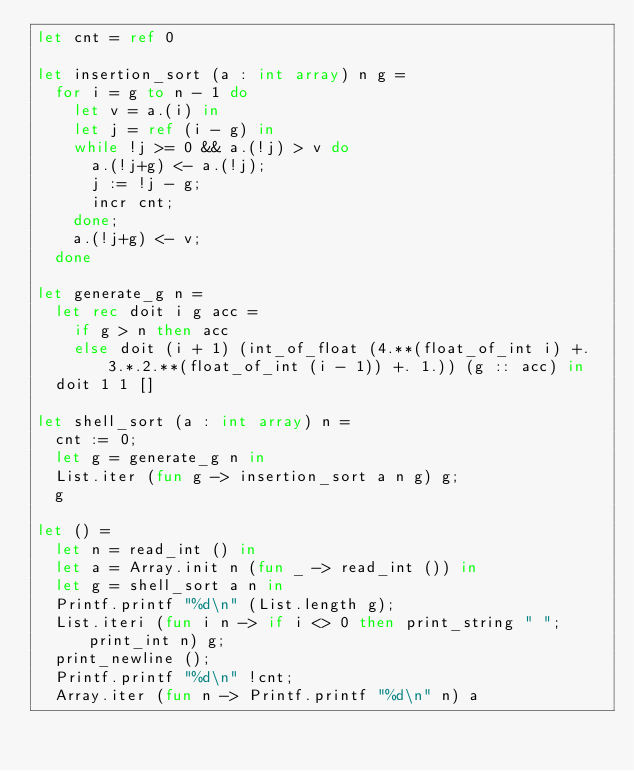Convert code to text. <code><loc_0><loc_0><loc_500><loc_500><_OCaml_>let cnt = ref 0

let insertion_sort (a : int array) n g =
  for i = g to n - 1 do
    let v = a.(i) in
    let j = ref (i - g) in
    while !j >= 0 && a.(!j) > v do
      a.(!j+g) <- a.(!j);
      j := !j - g;
      incr cnt;
    done;
    a.(!j+g) <- v;
  done

let generate_g n =
  let rec doit i g acc =
    if g > n then acc
    else doit (i + 1) (int_of_float (4.**(float_of_int i) +. 3.*.2.**(float_of_int (i - 1)) +. 1.)) (g :: acc) in
  doit 1 1 []

let shell_sort (a : int array) n =
  cnt := 0;
  let g = generate_g n in
  List.iter (fun g -> insertion_sort a n g) g;
  g

let () =
  let n = read_int () in
  let a = Array.init n (fun _ -> read_int ()) in
  let g = shell_sort a n in
  Printf.printf "%d\n" (List.length g);
  List.iteri (fun i n -> if i <> 0 then print_string " "; print_int n) g;
  print_newline ();
  Printf.printf "%d\n" !cnt;
  Array.iter (fun n -> Printf.printf "%d\n" n) a</code> 